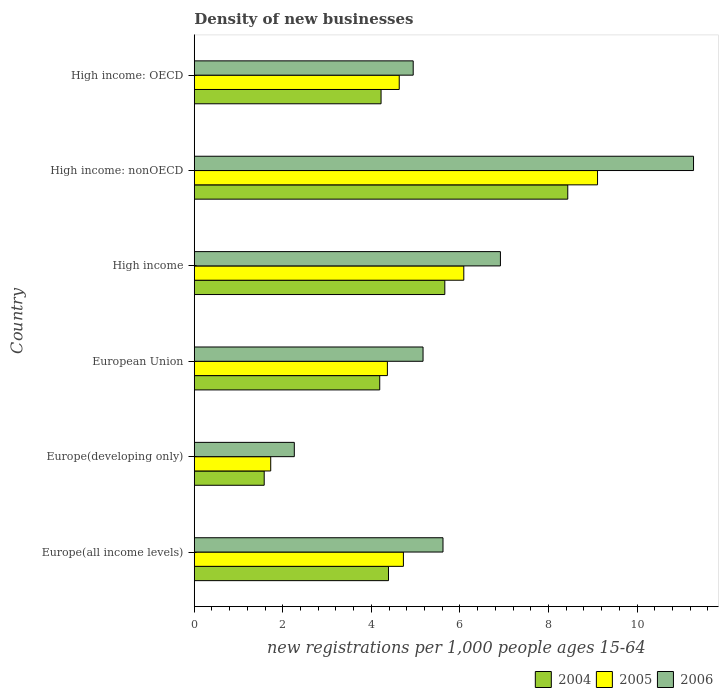How many different coloured bars are there?
Provide a short and direct response. 3. How many groups of bars are there?
Keep it short and to the point. 6. Are the number of bars per tick equal to the number of legend labels?
Keep it short and to the point. Yes. Are the number of bars on each tick of the Y-axis equal?
Give a very brief answer. Yes. How many bars are there on the 2nd tick from the bottom?
Give a very brief answer. 3. What is the label of the 5th group of bars from the top?
Provide a succinct answer. Europe(developing only). In how many cases, is the number of bars for a given country not equal to the number of legend labels?
Provide a succinct answer. 0. What is the number of new registrations in 2006 in Europe(developing only)?
Provide a short and direct response. 2.26. Across all countries, what is the maximum number of new registrations in 2005?
Make the answer very short. 9.11. Across all countries, what is the minimum number of new registrations in 2004?
Your response must be concise. 1.58. In which country was the number of new registrations in 2006 maximum?
Keep it short and to the point. High income: nonOECD. In which country was the number of new registrations in 2004 minimum?
Provide a short and direct response. Europe(developing only). What is the total number of new registrations in 2005 in the graph?
Offer a terse response. 30.64. What is the difference between the number of new registrations in 2005 in High income: OECD and that in High income: nonOECD?
Offer a terse response. -4.48. What is the difference between the number of new registrations in 2006 in Europe(all income levels) and the number of new registrations in 2005 in European Union?
Provide a succinct answer. 1.26. What is the average number of new registrations in 2006 per country?
Ensure brevity in your answer.  6.03. What is the difference between the number of new registrations in 2004 and number of new registrations in 2005 in European Union?
Provide a short and direct response. -0.17. In how many countries, is the number of new registrations in 2005 greater than 2.4 ?
Ensure brevity in your answer.  5. What is the ratio of the number of new registrations in 2004 in Europe(all income levels) to that in High income?
Your response must be concise. 0.78. Is the number of new registrations in 2006 in High income less than that in High income: nonOECD?
Offer a terse response. Yes. What is the difference between the highest and the second highest number of new registrations in 2004?
Offer a very short reply. 2.78. What is the difference between the highest and the lowest number of new registrations in 2004?
Your answer should be very brief. 6.86. In how many countries, is the number of new registrations in 2004 greater than the average number of new registrations in 2004 taken over all countries?
Offer a very short reply. 2. Is it the case that in every country, the sum of the number of new registrations in 2005 and number of new registrations in 2004 is greater than the number of new registrations in 2006?
Offer a terse response. Yes. Does the graph contain any zero values?
Provide a succinct answer. No. Does the graph contain grids?
Offer a terse response. No. Where does the legend appear in the graph?
Provide a short and direct response. Bottom right. How many legend labels are there?
Ensure brevity in your answer.  3. How are the legend labels stacked?
Your answer should be compact. Horizontal. What is the title of the graph?
Provide a succinct answer. Density of new businesses. Does "1983" appear as one of the legend labels in the graph?
Ensure brevity in your answer.  No. What is the label or title of the X-axis?
Your response must be concise. New registrations per 1,0 people ages 15-64. What is the label or title of the Y-axis?
Your answer should be compact. Country. What is the new registrations per 1,000 people ages 15-64 of 2004 in Europe(all income levels)?
Your answer should be compact. 4.39. What is the new registrations per 1,000 people ages 15-64 in 2005 in Europe(all income levels)?
Your answer should be compact. 4.72. What is the new registrations per 1,000 people ages 15-64 in 2006 in Europe(all income levels)?
Your answer should be very brief. 5.62. What is the new registrations per 1,000 people ages 15-64 of 2004 in Europe(developing only)?
Ensure brevity in your answer.  1.58. What is the new registrations per 1,000 people ages 15-64 in 2005 in Europe(developing only)?
Ensure brevity in your answer.  1.73. What is the new registrations per 1,000 people ages 15-64 of 2006 in Europe(developing only)?
Ensure brevity in your answer.  2.26. What is the new registrations per 1,000 people ages 15-64 of 2004 in European Union?
Your answer should be very brief. 4.19. What is the new registrations per 1,000 people ages 15-64 of 2005 in European Union?
Keep it short and to the point. 4.36. What is the new registrations per 1,000 people ages 15-64 of 2006 in European Union?
Your response must be concise. 5.17. What is the new registrations per 1,000 people ages 15-64 of 2004 in High income?
Make the answer very short. 5.66. What is the new registrations per 1,000 people ages 15-64 of 2005 in High income?
Keep it short and to the point. 6.09. What is the new registrations per 1,000 people ages 15-64 in 2006 in High income?
Offer a very short reply. 6.91. What is the new registrations per 1,000 people ages 15-64 of 2004 in High income: nonOECD?
Your answer should be very brief. 8.44. What is the new registrations per 1,000 people ages 15-64 in 2005 in High income: nonOECD?
Keep it short and to the point. 9.11. What is the new registrations per 1,000 people ages 15-64 in 2006 in High income: nonOECD?
Provide a succinct answer. 11.28. What is the new registrations per 1,000 people ages 15-64 of 2004 in High income: OECD?
Ensure brevity in your answer.  4.22. What is the new registrations per 1,000 people ages 15-64 in 2005 in High income: OECD?
Your response must be concise. 4.63. What is the new registrations per 1,000 people ages 15-64 of 2006 in High income: OECD?
Keep it short and to the point. 4.94. Across all countries, what is the maximum new registrations per 1,000 people ages 15-64 of 2004?
Your answer should be very brief. 8.44. Across all countries, what is the maximum new registrations per 1,000 people ages 15-64 in 2005?
Offer a terse response. 9.11. Across all countries, what is the maximum new registrations per 1,000 people ages 15-64 in 2006?
Your answer should be compact. 11.28. Across all countries, what is the minimum new registrations per 1,000 people ages 15-64 in 2004?
Provide a succinct answer. 1.58. Across all countries, what is the minimum new registrations per 1,000 people ages 15-64 in 2005?
Offer a very short reply. 1.73. Across all countries, what is the minimum new registrations per 1,000 people ages 15-64 of 2006?
Provide a short and direct response. 2.26. What is the total new registrations per 1,000 people ages 15-64 of 2004 in the graph?
Your answer should be compact. 28.47. What is the total new registrations per 1,000 people ages 15-64 in 2005 in the graph?
Ensure brevity in your answer.  30.64. What is the total new registrations per 1,000 people ages 15-64 of 2006 in the graph?
Keep it short and to the point. 36.18. What is the difference between the new registrations per 1,000 people ages 15-64 of 2004 in Europe(all income levels) and that in Europe(developing only)?
Provide a succinct answer. 2.81. What is the difference between the new registrations per 1,000 people ages 15-64 in 2005 in Europe(all income levels) and that in Europe(developing only)?
Make the answer very short. 3. What is the difference between the new registrations per 1,000 people ages 15-64 in 2006 in Europe(all income levels) and that in Europe(developing only)?
Give a very brief answer. 3.36. What is the difference between the new registrations per 1,000 people ages 15-64 of 2004 in Europe(all income levels) and that in European Union?
Ensure brevity in your answer.  0.2. What is the difference between the new registrations per 1,000 people ages 15-64 in 2005 in Europe(all income levels) and that in European Union?
Keep it short and to the point. 0.36. What is the difference between the new registrations per 1,000 people ages 15-64 of 2006 in Europe(all income levels) and that in European Union?
Your response must be concise. 0.45. What is the difference between the new registrations per 1,000 people ages 15-64 of 2004 in Europe(all income levels) and that in High income?
Keep it short and to the point. -1.27. What is the difference between the new registrations per 1,000 people ages 15-64 in 2005 in Europe(all income levels) and that in High income?
Your response must be concise. -1.36. What is the difference between the new registrations per 1,000 people ages 15-64 of 2006 in Europe(all income levels) and that in High income?
Offer a very short reply. -1.3. What is the difference between the new registrations per 1,000 people ages 15-64 of 2004 in Europe(all income levels) and that in High income: nonOECD?
Your answer should be compact. -4.05. What is the difference between the new registrations per 1,000 people ages 15-64 in 2005 in Europe(all income levels) and that in High income: nonOECD?
Your response must be concise. -4.38. What is the difference between the new registrations per 1,000 people ages 15-64 of 2006 in Europe(all income levels) and that in High income: nonOECD?
Offer a terse response. -5.66. What is the difference between the new registrations per 1,000 people ages 15-64 in 2004 in Europe(all income levels) and that in High income: OECD?
Make the answer very short. 0.17. What is the difference between the new registrations per 1,000 people ages 15-64 in 2005 in Europe(all income levels) and that in High income: OECD?
Ensure brevity in your answer.  0.09. What is the difference between the new registrations per 1,000 people ages 15-64 in 2006 in Europe(all income levels) and that in High income: OECD?
Make the answer very short. 0.67. What is the difference between the new registrations per 1,000 people ages 15-64 of 2004 in Europe(developing only) and that in European Union?
Your response must be concise. -2.61. What is the difference between the new registrations per 1,000 people ages 15-64 of 2005 in Europe(developing only) and that in European Union?
Your answer should be very brief. -2.64. What is the difference between the new registrations per 1,000 people ages 15-64 of 2006 in Europe(developing only) and that in European Union?
Your answer should be compact. -2.91. What is the difference between the new registrations per 1,000 people ages 15-64 of 2004 in Europe(developing only) and that in High income?
Ensure brevity in your answer.  -4.08. What is the difference between the new registrations per 1,000 people ages 15-64 of 2005 in Europe(developing only) and that in High income?
Provide a succinct answer. -4.36. What is the difference between the new registrations per 1,000 people ages 15-64 in 2006 in Europe(developing only) and that in High income?
Offer a very short reply. -4.66. What is the difference between the new registrations per 1,000 people ages 15-64 in 2004 in Europe(developing only) and that in High income: nonOECD?
Ensure brevity in your answer.  -6.86. What is the difference between the new registrations per 1,000 people ages 15-64 in 2005 in Europe(developing only) and that in High income: nonOECD?
Your response must be concise. -7.38. What is the difference between the new registrations per 1,000 people ages 15-64 in 2006 in Europe(developing only) and that in High income: nonOECD?
Ensure brevity in your answer.  -9.02. What is the difference between the new registrations per 1,000 people ages 15-64 in 2004 in Europe(developing only) and that in High income: OECD?
Give a very brief answer. -2.64. What is the difference between the new registrations per 1,000 people ages 15-64 of 2005 in Europe(developing only) and that in High income: OECD?
Your response must be concise. -2.9. What is the difference between the new registrations per 1,000 people ages 15-64 in 2006 in Europe(developing only) and that in High income: OECD?
Provide a succinct answer. -2.69. What is the difference between the new registrations per 1,000 people ages 15-64 of 2004 in European Union and that in High income?
Offer a terse response. -1.47. What is the difference between the new registrations per 1,000 people ages 15-64 of 2005 in European Union and that in High income?
Your response must be concise. -1.73. What is the difference between the new registrations per 1,000 people ages 15-64 of 2006 in European Union and that in High income?
Provide a short and direct response. -1.75. What is the difference between the new registrations per 1,000 people ages 15-64 of 2004 in European Union and that in High income: nonOECD?
Give a very brief answer. -4.25. What is the difference between the new registrations per 1,000 people ages 15-64 in 2005 in European Union and that in High income: nonOECD?
Your response must be concise. -4.75. What is the difference between the new registrations per 1,000 people ages 15-64 in 2006 in European Union and that in High income: nonOECD?
Keep it short and to the point. -6.11. What is the difference between the new registrations per 1,000 people ages 15-64 of 2004 in European Union and that in High income: OECD?
Your response must be concise. -0.03. What is the difference between the new registrations per 1,000 people ages 15-64 in 2005 in European Union and that in High income: OECD?
Make the answer very short. -0.27. What is the difference between the new registrations per 1,000 people ages 15-64 of 2006 in European Union and that in High income: OECD?
Give a very brief answer. 0.22. What is the difference between the new registrations per 1,000 people ages 15-64 in 2004 in High income and that in High income: nonOECD?
Ensure brevity in your answer.  -2.78. What is the difference between the new registrations per 1,000 people ages 15-64 in 2005 in High income and that in High income: nonOECD?
Your answer should be compact. -3.02. What is the difference between the new registrations per 1,000 people ages 15-64 of 2006 in High income and that in High income: nonOECD?
Give a very brief answer. -4.36. What is the difference between the new registrations per 1,000 people ages 15-64 in 2004 in High income and that in High income: OECD?
Keep it short and to the point. 1.44. What is the difference between the new registrations per 1,000 people ages 15-64 in 2005 in High income and that in High income: OECD?
Offer a terse response. 1.46. What is the difference between the new registrations per 1,000 people ages 15-64 of 2006 in High income and that in High income: OECD?
Give a very brief answer. 1.97. What is the difference between the new registrations per 1,000 people ages 15-64 of 2004 in High income: nonOECD and that in High income: OECD?
Provide a succinct answer. 4.22. What is the difference between the new registrations per 1,000 people ages 15-64 in 2005 in High income: nonOECD and that in High income: OECD?
Make the answer very short. 4.48. What is the difference between the new registrations per 1,000 people ages 15-64 in 2006 in High income: nonOECD and that in High income: OECD?
Make the answer very short. 6.33. What is the difference between the new registrations per 1,000 people ages 15-64 in 2004 in Europe(all income levels) and the new registrations per 1,000 people ages 15-64 in 2005 in Europe(developing only)?
Give a very brief answer. 2.66. What is the difference between the new registrations per 1,000 people ages 15-64 of 2004 in Europe(all income levels) and the new registrations per 1,000 people ages 15-64 of 2006 in Europe(developing only)?
Give a very brief answer. 2.13. What is the difference between the new registrations per 1,000 people ages 15-64 of 2005 in Europe(all income levels) and the new registrations per 1,000 people ages 15-64 of 2006 in Europe(developing only)?
Make the answer very short. 2.46. What is the difference between the new registrations per 1,000 people ages 15-64 of 2004 in Europe(all income levels) and the new registrations per 1,000 people ages 15-64 of 2005 in European Union?
Provide a succinct answer. 0.02. What is the difference between the new registrations per 1,000 people ages 15-64 in 2004 in Europe(all income levels) and the new registrations per 1,000 people ages 15-64 in 2006 in European Union?
Give a very brief answer. -0.78. What is the difference between the new registrations per 1,000 people ages 15-64 of 2005 in Europe(all income levels) and the new registrations per 1,000 people ages 15-64 of 2006 in European Union?
Make the answer very short. -0.44. What is the difference between the new registrations per 1,000 people ages 15-64 of 2004 in Europe(all income levels) and the new registrations per 1,000 people ages 15-64 of 2005 in High income?
Provide a succinct answer. -1.7. What is the difference between the new registrations per 1,000 people ages 15-64 in 2004 in Europe(all income levels) and the new registrations per 1,000 people ages 15-64 in 2006 in High income?
Provide a short and direct response. -2.53. What is the difference between the new registrations per 1,000 people ages 15-64 of 2005 in Europe(all income levels) and the new registrations per 1,000 people ages 15-64 of 2006 in High income?
Your answer should be compact. -2.19. What is the difference between the new registrations per 1,000 people ages 15-64 in 2004 in Europe(all income levels) and the new registrations per 1,000 people ages 15-64 in 2005 in High income: nonOECD?
Ensure brevity in your answer.  -4.72. What is the difference between the new registrations per 1,000 people ages 15-64 of 2004 in Europe(all income levels) and the new registrations per 1,000 people ages 15-64 of 2006 in High income: nonOECD?
Your answer should be compact. -6.89. What is the difference between the new registrations per 1,000 people ages 15-64 of 2005 in Europe(all income levels) and the new registrations per 1,000 people ages 15-64 of 2006 in High income: nonOECD?
Your answer should be compact. -6.55. What is the difference between the new registrations per 1,000 people ages 15-64 of 2004 in Europe(all income levels) and the new registrations per 1,000 people ages 15-64 of 2005 in High income: OECD?
Provide a succinct answer. -0.24. What is the difference between the new registrations per 1,000 people ages 15-64 in 2004 in Europe(all income levels) and the new registrations per 1,000 people ages 15-64 in 2006 in High income: OECD?
Keep it short and to the point. -0.56. What is the difference between the new registrations per 1,000 people ages 15-64 of 2005 in Europe(all income levels) and the new registrations per 1,000 people ages 15-64 of 2006 in High income: OECD?
Offer a very short reply. -0.22. What is the difference between the new registrations per 1,000 people ages 15-64 in 2004 in Europe(developing only) and the new registrations per 1,000 people ages 15-64 in 2005 in European Union?
Your answer should be compact. -2.78. What is the difference between the new registrations per 1,000 people ages 15-64 in 2004 in Europe(developing only) and the new registrations per 1,000 people ages 15-64 in 2006 in European Union?
Offer a terse response. -3.59. What is the difference between the new registrations per 1,000 people ages 15-64 of 2005 in Europe(developing only) and the new registrations per 1,000 people ages 15-64 of 2006 in European Union?
Ensure brevity in your answer.  -3.44. What is the difference between the new registrations per 1,000 people ages 15-64 of 2004 in Europe(developing only) and the new registrations per 1,000 people ages 15-64 of 2005 in High income?
Keep it short and to the point. -4.51. What is the difference between the new registrations per 1,000 people ages 15-64 in 2004 in Europe(developing only) and the new registrations per 1,000 people ages 15-64 in 2006 in High income?
Your answer should be compact. -5.33. What is the difference between the new registrations per 1,000 people ages 15-64 of 2005 in Europe(developing only) and the new registrations per 1,000 people ages 15-64 of 2006 in High income?
Offer a terse response. -5.19. What is the difference between the new registrations per 1,000 people ages 15-64 in 2004 in Europe(developing only) and the new registrations per 1,000 people ages 15-64 in 2005 in High income: nonOECD?
Your answer should be very brief. -7.53. What is the difference between the new registrations per 1,000 people ages 15-64 of 2004 in Europe(developing only) and the new registrations per 1,000 people ages 15-64 of 2006 in High income: nonOECD?
Make the answer very short. -9.7. What is the difference between the new registrations per 1,000 people ages 15-64 in 2005 in Europe(developing only) and the new registrations per 1,000 people ages 15-64 in 2006 in High income: nonOECD?
Provide a succinct answer. -9.55. What is the difference between the new registrations per 1,000 people ages 15-64 of 2004 in Europe(developing only) and the new registrations per 1,000 people ages 15-64 of 2005 in High income: OECD?
Your response must be concise. -3.05. What is the difference between the new registrations per 1,000 people ages 15-64 of 2004 in Europe(developing only) and the new registrations per 1,000 people ages 15-64 of 2006 in High income: OECD?
Your answer should be compact. -3.37. What is the difference between the new registrations per 1,000 people ages 15-64 of 2005 in Europe(developing only) and the new registrations per 1,000 people ages 15-64 of 2006 in High income: OECD?
Give a very brief answer. -3.22. What is the difference between the new registrations per 1,000 people ages 15-64 of 2004 in European Union and the new registrations per 1,000 people ages 15-64 of 2005 in High income?
Offer a terse response. -1.9. What is the difference between the new registrations per 1,000 people ages 15-64 of 2004 in European Union and the new registrations per 1,000 people ages 15-64 of 2006 in High income?
Keep it short and to the point. -2.73. What is the difference between the new registrations per 1,000 people ages 15-64 of 2005 in European Union and the new registrations per 1,000 people ages 15-64 of 2006 in High income?
Offer a very short reply. -2.55. What is the difference between the new registrations per 1,000 people ages 15-64 in 2004 in European Union and the new registrations per 1,000 people ages 15-64 in 2005 in High income: nonOECD?
Make the answer very short. -4.92. What is the difference between the new registrations per 1,000 people ages 15-64 in 2004 in European Union and the new registrations per 1,000 people ages 15-64 in 2006 in High income: nonOECD?
Ensure brevity in your answer.  -7.09. What is the difference between the new registrations per 1,000 people ages 15-64 of 2005 in European Union and the new registrations per 1,000 people ages 15-64 of 2006 in High income: nonOECD?
Your answer should be very brief. -6.91. What is the difference between the new registrations per 1,000 people ages 15-64 of 2004 in European Union and the new registrations per 1,000 people ages 15-64 of 2005 in High income: OECD?
Make the answer very short. -0.44. What is the difference between the new registrations per 1,000 people ages 15-64 in 2004 in European Union and the new registrations per 1,000 people ages 15-64 in 2006 in High income: OECD?
Your answer should be very brief. -0.76. What is the difference between the new registrations per 1,000 people ages 15-64 of 2005 in European Union and the new registrations per 1,000 people ages 15-64 of 2006 in High income: OECD?
Provide a short and direct response. -0.58. What is the difference between the new registrations per 1,000 people ages 15-64 of 2004 in High income and the new registrations per 1,000 people ages 15-64 of 2005 in High income: nonOECD?
Keep it short and to the point. -3.45. What is the difference between the new registrations per 1,000 people ages 15-64 of 2004 in High income and the new registrations per 1,000 people ages 15-64 of 2006 in High income: nonOECD?
Keep it short and to the point. -5.62. What is the difference between the new registrations per 1,000 people ages 15-64 in 2005 in High income and the new registrations per 1,000 people ages 15-64 in 2006 in High income: nonOECD?
Your answer should be very brief. -5.19. What is the difference between the new registrations per 1,000 people ages 15-64 in 2004 in High income and the new registrations per 1,000 people ages 15-64 in 2005 in High income: OECD?
Your response must be concise. 1.03. What is the difference between the new registrations per 1,000 people ages 15-64 in 2004 in High income and the new registrations per 1,000 people ages 15-64 in 2006 in High income: OECD?
Your response must be concise. 0.71. What is the difference between the new registrations per 1,000 people ages 15-64 in 2005 in High income and the new registrations per 1,000 people ages 15-64 in 2006 in High income: OECD?
Offer a very short reply. 1.14. What is the difference between the new registrations per 1,000 people ages 15-64 of 2004 in High income: nonOECD and the new registrations per 1,000 people ages 15-64 of 2005 in High income: OECD?
Give a very brief answer. 3.81. What is the difference between the new registrations per 1,000 people ages 15-64 in 2004 in High income: nonOECD and the new registrations per 1,000 people ages 15-64 in 2006 in High income: OECD?
Keep it short and to the point. 3.49. What is the difference between the new registrations per 1,000 people ages 15-64 in 2005 in High income: nonOECD and the new registrations per 1,000 people ages 15-64 in 2006 in High income: OECD?
Your answer should be compact. 4.16. What is the average new registrations per 1,000 people ages 15-64 of 2004 per country?
Provide a short and direct response. 4.74. What is the average new registrations per 1,000 people ages 15-64 of 2005 per country?
Your response must be concise. 5.11. What is the average new registrations per 1,000 people ages 15-64 in 2006 per country?
Your answer should be compact. 6.03. What is the difference between the new registrations per 1,000 people ages 15-64 in 2004 and new registrations per 1,000 people ages 15-64 in 2005 in Europe(all income levels)?
Offer a very short reply. -0.34. What is the difference between the new registrations per 1,000 people ages 15-64 of 2004 and new registrations per 1,000 people ages 15-64 of 2006 in Europe(all income levels)?
Provide a short and direct response. -1.23. What is the difference between the new registrations per 1,000 people ages 15-64 of 2005 and new registrations per 1,000 people ages 15-64 of 2006 in Europe(all income levels)?
Your answer should be compact. -0.89. What is the difference between the new registrations per 1,000 people ages 15-64 of 2004 and new registrations per 1,000 people ages 15-64 of 2005 in Europe(developing only)?
Your response must be concise. -0.15. What is the difference between the new registrations per 1,000 people ages 15-64 of 2004 and new registrations per 1,000 people ages 15-64 of 2006 in Europe(developing only)?
Give a very brief answer. -0.68. What is the difference between the new registrations per 1,000 people ages 15-64 of 2005 and new registrations per 1,000 people ages 15-64 of 2006 in Europe(developing only)?
Offer a terse response. -0.53. What is the difference between the new registrations per 1,000 people ages 15-64 in 2004 and new registrations per 1,000 people ages 15-64 in 2005 in European Union?
Your response must be concise. -0.17. What is the difference between the new registrations per 1,000 people ages 15-64 of 2004 and new registrations per 1,000 people ages 15-64 of 2006 in European Union?
Your answer should be compact. -0.98. What is the difference between the new registrations per 1,000 people ages 15-64 in 2005 and new registrations per 1,000 people ages 15-64 in 2006 in European Union?
Offer a very short reply. -0.81. What is the difference between the new registrations per 1,000 people ages 15-64 in 2004 and new registrations per 1,000 people ages 15-64 in 2005 in High income?
Offer a very short reply. -0.43. What is the difference between the new registrations per 1,000 people ages 15-64 of 2004 and new registrations per 1,000 people ages 15-64 of 2006 in High income?
Keep it short and to the point. -1.26. What is the difference between the new registrations per 1,000 people ages 15-64 of 2005 and new registrations per 1,000 people ages 15-64 of 2006 in High income?
Ensure brevity in your answer.  -0.83. What is the difference between the new registrations per 1,000 people ages 15-64 of 2004 and new registrations per 1,000 people ages 15-64 of 2005 in High income: nonOECD?
Provide a succinct answer. -0.67. What is the difference between the new registrations per 1,000 people ages 15-64 in 2004 and new registrations per 1,000 people ages 15-64 in 2006 in High income: nonOECD?
Offer a very short reply. -2.84. What is the difference between the new registrations per 1,000 people ages 15-64 in 2005 and new registrations per 1,000 people ages 15-64 in 2006 in High income: nonOECD?
Offer a terse response. -2.17. What is the difference between the new registrations per 1,000 people ages 15-64 in 2004 and new registrations per 1,000 people ages 15-64 in 2005 in High income: OECD?
Provide a short and direct response. -0.41. What is the difference between the new registrations per 1,000 people ages 15-64 of 2004 and new registrations per 1,000 people ages 15-64 of 2006 in High income: OECD?
Your response must be concise. -0.73. What is the difference between the new registrations per 1,000 people ages 15-64 in 2005 and new registrations per 1,000 people ages 15-64 in 2006 in High income: OECD?
Offer a terse response. -0.32. What is the ratio of the new registrations per 1,000 people ages 15-64 in 2004 in Europe(all income levels) to that in Europe(developing only)?
Provide a short and direct response. 2.78. What is the ratio of the new registrations per 1,000 people ages 15-64 in 2005 in Europe(all income levels) to that in Europe(developing only)?
Ensure brevity in your answer.  2.74. What is the ratio of the new registrations per 1,000 people ages 15-64 of 2006 in Europe(all income levels) to that in Europe(developing only)?
Make the answer very short. 2.49. What is the ratio of the new registrations per 1,000 people ages 15-64 in 2004 in Europe(all income levels) to that in European Union?
Offer a terse response. 1.05. What is the ratio of the new registrations per 1,000 people ages 15-64 of 2005 in Europe(all income levels) to that in European Union?
Make the answer very short. 1.08. What is the ratio of the new registrations per 1,000 people ages 15-64 of 2006 in Europe(all income levels) to that in European Union?
Make the answer very short. 1.09. What is the ratio of the new registrations per 1,000 people ages 15-64 of 2004 in Europe(all income levels) to that in High income?
Keep it short and to the point. 0.78. What is the ratio of the new registrations per 1,000 people ages 15-64 in 2005 in Europe(all income levels) to that in High income?
Make the answer very short. 0.78. What is the ratio of the new registrations per 1,000 people ages 15-64 of 2006 in Europe(all income levels) to that in High income?
Offer a very short reply. 0.81. What is the ratio of the new registrations per 1,000 people ages 15-64 in 2004 in Europe(all income levels) to that in High income: nonOECD?
Give a very brief answer. 0.52. What is the ratio of the new registrations per 1,000 people ages 15-64 of 2005 in Europe(all income levels) to that in High income: nonOECD?
Make the answer very short. 0.52. What is the ratio of the new registrations per 1,000 people ages 15-64 in 2006 in Europe(all income levels) to that in High income: nonOECD?
Make the answer very short. 0.5. What is the ratio of the new registrations per 1,000 people ages 15-64 in 2004 in Europe(all income levels) to that in High income: OECD?
Your response must be concise. 1.04. What is the ratio of the new registrations per 1,000 people ages 15-64 in 2005 in Europe(all income levels) to that in High income: OECD?
Make the answer very short. 1.02. What is the ratio of the new registrations per 1,000 people ages 15-64 in 2006 in Europe(all income levels) to that in High income: OECD?
Provide a short and direct response. 1.14. What is the ratio of the new registrations per 1,000 people ages 15-64 in 2004 in Europe(developing only) to that in European Union?
Your response must be concise. 0.38. What is the ratio of the new registrations per 1,000 people ages 15-64 in 2005 in Europe(developing only) to that in European Union?
Your response must be concise. 0.4. What is the ratio of the new registrations per 1,000 people ages 15-64 in 2006 in Europe(developing only) to that in European Union?
Your response must be concise. 0.44. What is the ratio of the new registrations per 1,000 people ages 15-64 of 2004 in Europe(developing only) to that in High income?
Offer a very short reply. 0.28. What is the ratio of the new registrations per 1,000 people ages 15-64 of 2005 in Europe(developing only) to that in High income?
Give a very brief answer. 0.28. What is the ratio of the new registrations per 1,000 people ages 15-64 of 2006 in Europe(developing only) to that in High income?
Provide a short and direct response. 0.33. What is the ratio of the new registrations per 1,000 people ages 15-64 of 2004 in Europe(developing only) to that in High income: nonOECD?
Your answer should be very brief. 0.19. What is the ratio of the new registrations per 1,000 people ages 15-64 of 2005 in Europe(developing only) to that in High income: nonOECD?
Your answer should be very brief. 0.19. What is the ratio of the new registrations per 1,000 people ages 15-64 in 2006 in Europe(developing only) to that in High income: nonOECD?
Your answer should be compact. 0.2. What is the ratio of the new registrations per 1,000 people ages 15-64 of 2004 in Europe(developing only) to that in High income: OECD?
Offer a very short reply. 0.37. What is the ratio of the new registrations per 1,000 people ages 15-64 in 2005 in Europe(developing only) to that in High income: OECD?
Ensure brevity in your answer.  0.37. What is the ratio of the new registrations per 1,000 people ages 15-64 in 2006 in Europe(developing only) to that in High income: OECD?
Offer a very short reply. 0.46. What is the ratio of the new registrations per 1,000 people ages 15-64 in 2004 in European Union to that in High income?
Offer a terse response. 0.74. What is the ratio of the new registrations per 1,000 people ages 15-64 in 2005 in European Union to that in High income?
Provide a short and direct response. 0.72. What is the ratio of the new registrations per 1,000 people ages 15-64 of 2006 in European Union to that in High income?
Offer a terse response. 0.75. What is the ratio of the new registrations per 1,000 people ages 15-64 of 2004 in European Union to that in High income: nonOECD?
Your answer should be very brief. 0.5. What is the ratio of the new registrations per 1,000 people ages 15-64 of 2005 in European Union to that in High income: nonOECD?
Your answer should be compact. 0.48. What is the ratio of the new registrations per 1,000 people ages 15-64 in 2006 in European Union to that in High income: nonOECD?
Give a very brief answer. 0.46. What is the ratio of the new registrations per 1,000 people ages 15-64 in 2004 in European Union to that in High income: OECD?
Offer a very short reply. 0.99. What is the ratio of the new registrations per 1,000 people ages 15-64 in 2005 in European Union to that in High income: OECD?
Give a very brief answer. 0.94. What is the ratio of the new registrations per 1,000 people ages 15-64 in 2006 in European Union to that in High income: OECD?
Your answer should be compact. 1.04. What is the ratio of the new registrations per 1,000 people ages 15-64 of 2004 in High income to that in High income: nonOECD?
Offer a very short reply. 0.67. What is the ratio of the new registrations per 1,000 people ages 15-64 of 2005 in High income to that in High income: nonOECD?
Make the answer very short. 0.67. What is the ratio of the new registrations per 1,000 people ages 15-64 of 2006 in High income to that in High income: nonOECD?
Keep it short and to the point. 0.61. What is the ratio of the new registrations per 1,000 people ages 15-64 in 2004 in High income to that in High income: OECD?
Provide a succinct answer. 1.34. What is the ratio of the new registrations per 1,000 people ages 15-64 of 2005 in High income to that in High income: OECD?
Give a very brief answer. 1.31. What is the ratio of the new registrations per 1,000 people ages 15-64 in 2006 in High income to that in High income: OECD?
Offer a terse response. 1.4. What is the ratio of the new registrations per 1,000 people ages 15-64 of 2004 in High income: nonOECD to that in High income: OECD?
Provide a short and direct response. 2. What is the ratio of the new registrations per 1,000 people ages 15-64 in 2005 in High income: nonOECD to that in High income: OECD?
Provide a succinct answer. 1.97. What is the ratio of the new registrations per 1,000 people ages 15-64 in 2006 in High income: nonOECD to that in High income: OECD?
Provide a short and direct response. 2.28. What is the difference between the highest and the second highest new registrations per 1,000 people ages 15-64 of 2004?
Your answer should be very brief. 2.78. What is the difference between the highest and the second highest new registrations per 1,000 people ages 15-64 of 2005?
Provide a succinct answer. 3.02. What is the difference between the highest and the second highest new registrations per 1,000 people ages 15-64 in 2006?
Provide a succinct answer. 4.36. What is the difference between the highest and the lowest new registrations per 1,000 people ages 15-64 of 2004?
Make the answer very short. 6.86. What is the difference between the highest and the lowest new registrations per 1,000 people ages 15-64 of 2005?
Offer a terse response. 7.38. What is the difference between the highest and the lowest new registrations per 1,000 people ages 15-64 in 2006?
Your answer should be compact. 9.02. 